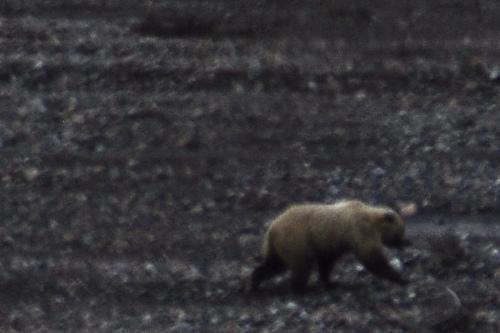How many bears are in this picture?
Give a very brief answer. 1. 